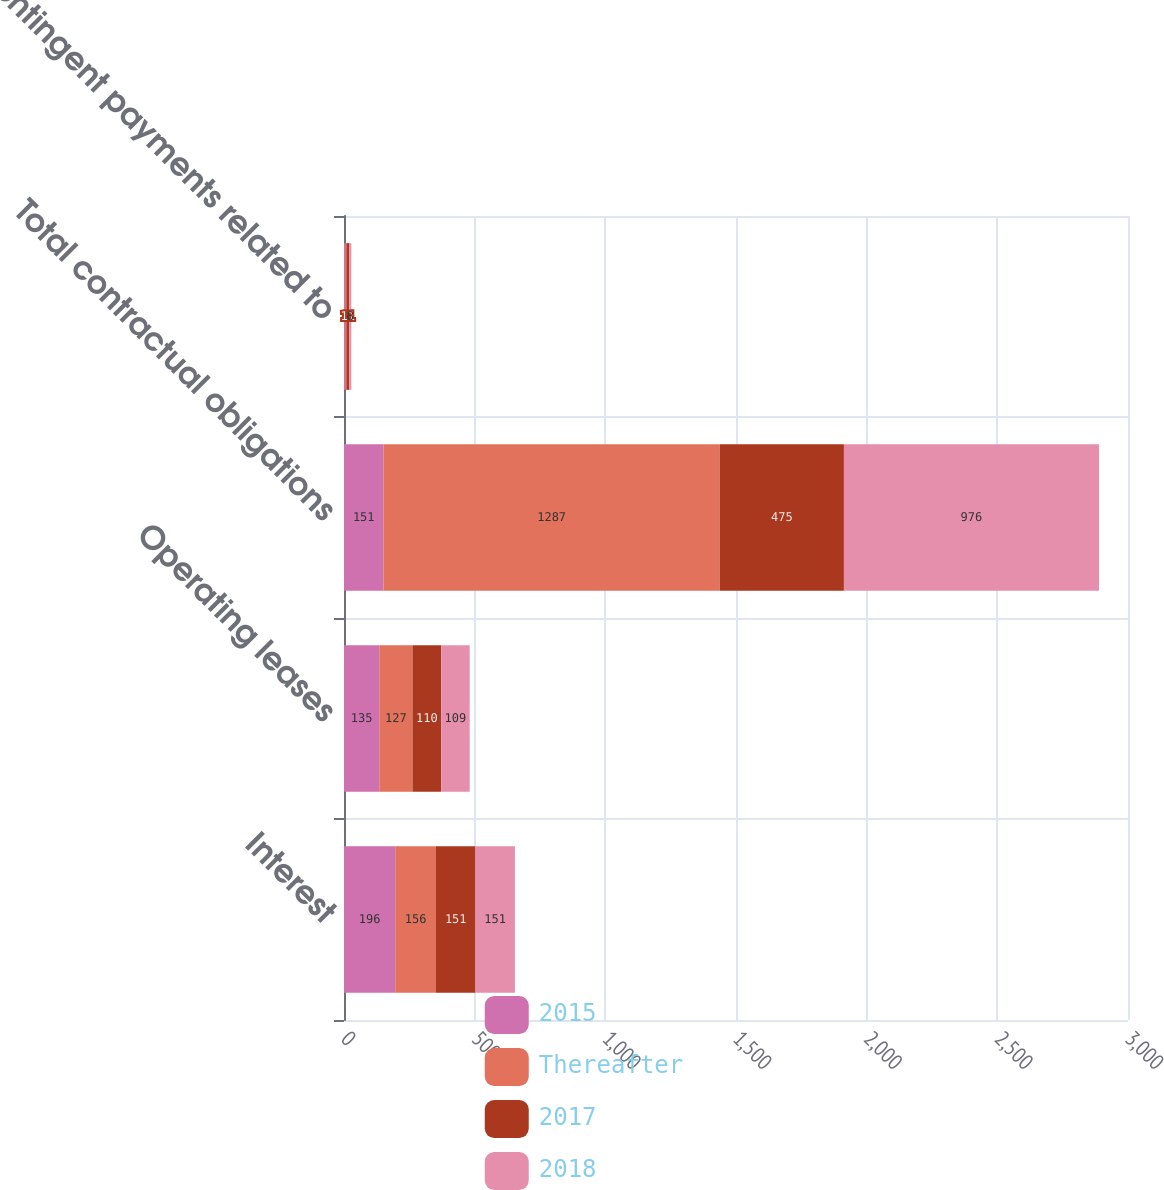Convert chart to OTSL. <chart><loc_0><loc_0><loc_500><loc_500><stacked_bar_chart><ecel><fcel>Interest<fcel>Operating leases<fcel>Total contractual obligations<fcel>Contingent payments related to<nl><fcel>2015<fcel>196<fcel>135<fcel>151<fcel>4<nl><fcel>Thereafter<fcel>156<fcel>127<fcel>1287<fcel>5<nl><fcel>2017<fcel>151<fcel>110<fcel>475<fcel>11<nl><fcel>2018<fcel>151<fcel>109<fcel>976<fcel>8<nl></chart> 